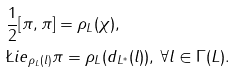Convert formula to latex. <formula><loc_0><loc_0><loc_500><loc_500>& \frac { 1 } { 2 } [ \pi , \pi ] = \rho _ { L } ( \chi ) , \\ & \L i e _ { \rho _ { L } ( l ) } \pi = \rho _ { L } ( d _ { L ^ { * } } ( l ) ) , \, \forall l \in \Gamma ( L ) .</formula> 